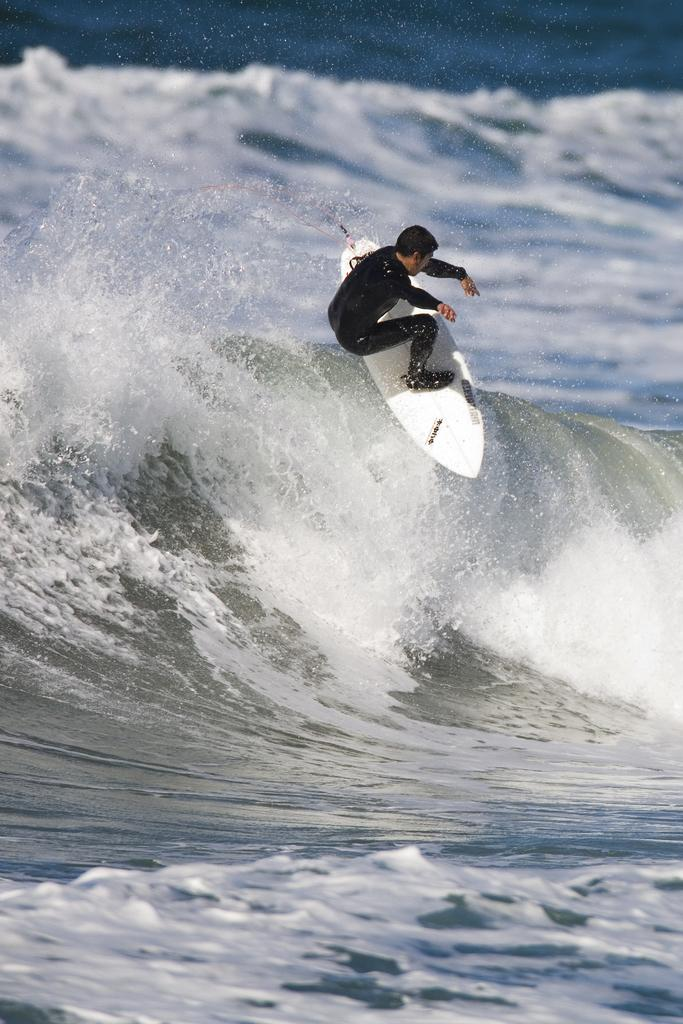What is the main subject of the image? There is a man in the image. What is the man doing in the image? The man is surfing on the waves. What is the man wearing while surfing? The man is wearing a black costume. What time of day is the camera capturing the man surfing in the image? The provided facts do not mention a camera or the time of day, so we cannot determine when the image was captured. 